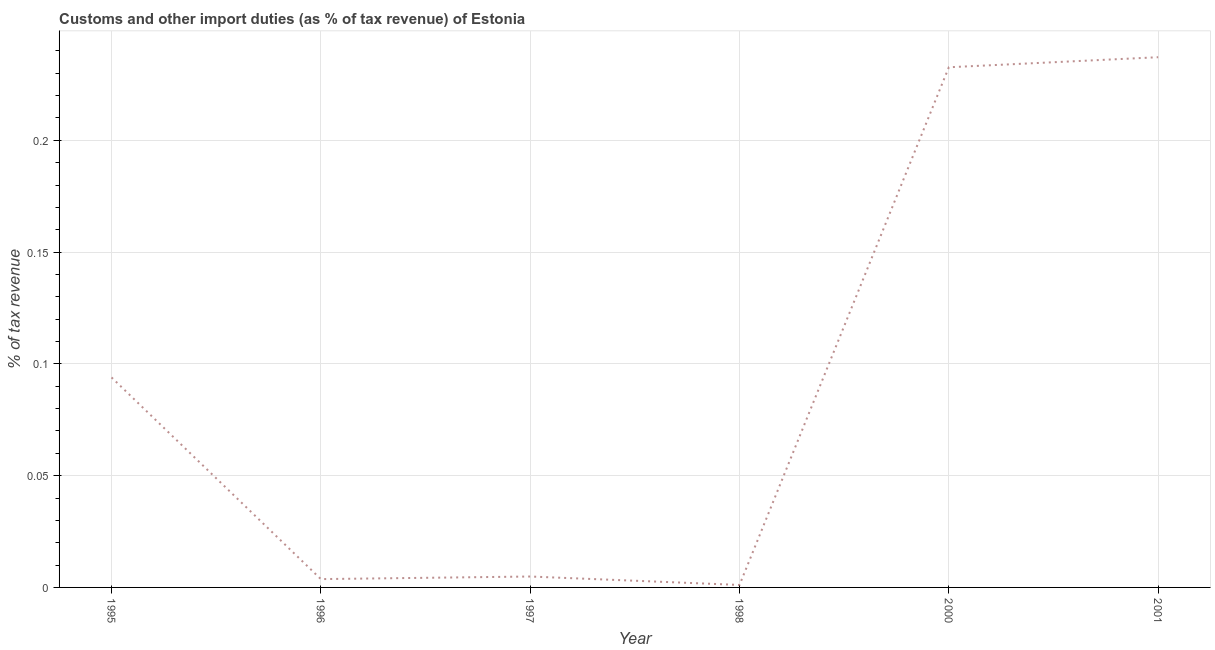What is the customs and other import duties in 2000?
Provide a short and direct response. 0.23. Across all years, what is the maximum customs and other import duties?
Keep it short and to the point. 0.24. Across all years, what is the minimum customs and other import duties?
Your answer should be compact. 0. In which year was the customs and other import duties maximum?
Give a very brief answer. 2001. In which year was the customs and other import duties minimum?
Make the answer very short. 1998. What is the sum of the customs and other import duties?
Offer a terse response. 0.57. What is the difference between the customs and other import duties in 1998 and 2001?
Provide a short and direct response. -0.24. What is the average customs and other import duties per year?
Offer a very short reply. 0.1. What is the median customs and other import duties?
Ensure brevity in your answer.  0.05. In how many years, is the customs and other import duties greater than 0.01 %?
Provide a succinct answer. 3. What is the ratio of the customs and other import duties in 1996 to that in 1998?
Ensure brevity in your answer.  3.36. Is the customs and other import duties in 1996 less than that in 2000?
Your answer should be compact. Yes. What is the difference between the highest and the second highest customs and other import duties?
Your answer should be very brief. 0. Is the sum of the customs and other import duties in 1996 and 2001 greater than the maximum customs and other import duties across all years?
Make the answer very short. Yes. What is the difference between the highest and the lowest customs and other import duties?
Provide a short and direct response. 0.24. In how many years, is the customs and other import duties greater than the average customs and other import duties taken over all years?
Your answer should be compact. 2. How many years are there in the graph?
Make the answer very short. 6. Does the graph contain grids?
Make the answer very short. Yes. What is the title of the graph?
Keep it short and to the point. Customs and other import duties (as % of tax revenue) of Estonia. What is the label or title of the X-axis?
Provide a succinct answer. Year. What is the label or title of the Y-axis?
Provide a succinct answer. % of tax revenue. What is the % of tax revenue in 1995?
Offer a terse response. 0.09. What is the % of tax revenue in 1996?
Provide a succinct answer. 0. What is the % of tax revenue in 1997?
Offer a terse response. 0. What is the % of tax revenue of 1998?
Provide a short and direct response. 0. What is the % of tax revenue in 2000?
Offer a very short reply. 0.23. What is the % of tax revenue in 2001?
Your response must be concise. 0.24. What is the difference between the % of tax revenue in 1995 and 1996?
Your answer should be very brief. 0.09. What is the difference between the % of tax revenue in 1995 and 1997?
Make the answer very short. 0.09. What is the difference between the % of tax revenue in 1995 and 1998?
Give a very brief answer. 0.09. What is the difference between the % of tax revenue in 1995 and 2000?
Your answer should be very brief. -0.14. What is the difference between the % of tax revenue in 1995 and 2001?
Provide a short and direct response. -0.14. What is the difference between the % of tax revenue in 1996 and 1997?
Ensure brevity in your answer.  -0. What is the difference between the % of tax revenue in 1996 and 1998?
Offer a terse response. 0. What is the difference between the % of tax revenue in 1996 and 2000?
Offer a very short reply. -0.23. What is the difference between the % of tax revenue in 1996 and 2001?
Ensure brevity in your answer.  -0.23. What is the difference between the % of tax revenue in 1997 and 1998?
Ensure brevity in your answer.  0. What is the difference between the % of tax revenue in 1997 and 2000?
Provide a short and direct response. -0.23. What is the difference between the % of tax revenue in 1997 and 2001?
Offer a terse response. -0.23. What is the difference between the % of tax revenue in 1998 and 2000?
Give a very brief answer. -0.23. What is the difference between the % of tax revenue in 1998 and 2001?
Give a very brief answer. -0.24. What is the difference between the % of tax revenue in 2000 and 2001?
Provide a succinct answer. -0. What is the ratio of the % of tax revenue in 1995 to that in 1996?
Your response must be concise. 25.24. What is the ratio of the % of tax revenue in 1995 to that in 1997?
Offer a very short reply. 19.25. What is the ratio of the % of tax revenue in 1995 to that in 1998?
Give a very brief answer. 84.87. What is the ratio of the % of tax revenue in 1995 to that in 2000?
Provide a succinct answer. 0.4. What is the ratio of the % of tax revenue in 1995 to that in 2001?
Ensure brevity in your answer.  0.4. What is the ratio of the % of tax revenue in 1996 to that in 1997?
Ensure brevity in your answer.  0.76. What is the ratio of the % of tax revenue in 1996 to that in 1998?
Provide a succinct answer. 3.36. What is the ratio of the % of tax revenue in 1996 to that in 2000?
Provide a short and direct response. 0.02. What is the ratio of the % of tax revenue in 1996 to that in 2001?
Make the answer very short. 0.02. What is the ratio of the % of tax revenue in 1997 to that in 1998?
Make the answer very short. 4.41. What is the ratio of the % of tax revenue in 1997 to that in 2000?
Your response must be concise. 0.02. What is the ratio of the % of tax revenue in 1997 to that in 2001?
Give a very brief answer. 0.02. What is the ratio of the % of tax revenue in 1998 to that in 2000?
Your answer should be very brief. 0.01. What is the ratio of the % of tax revenue in 1998 to that in 2001?
Your answer should be compact. 0.01. 